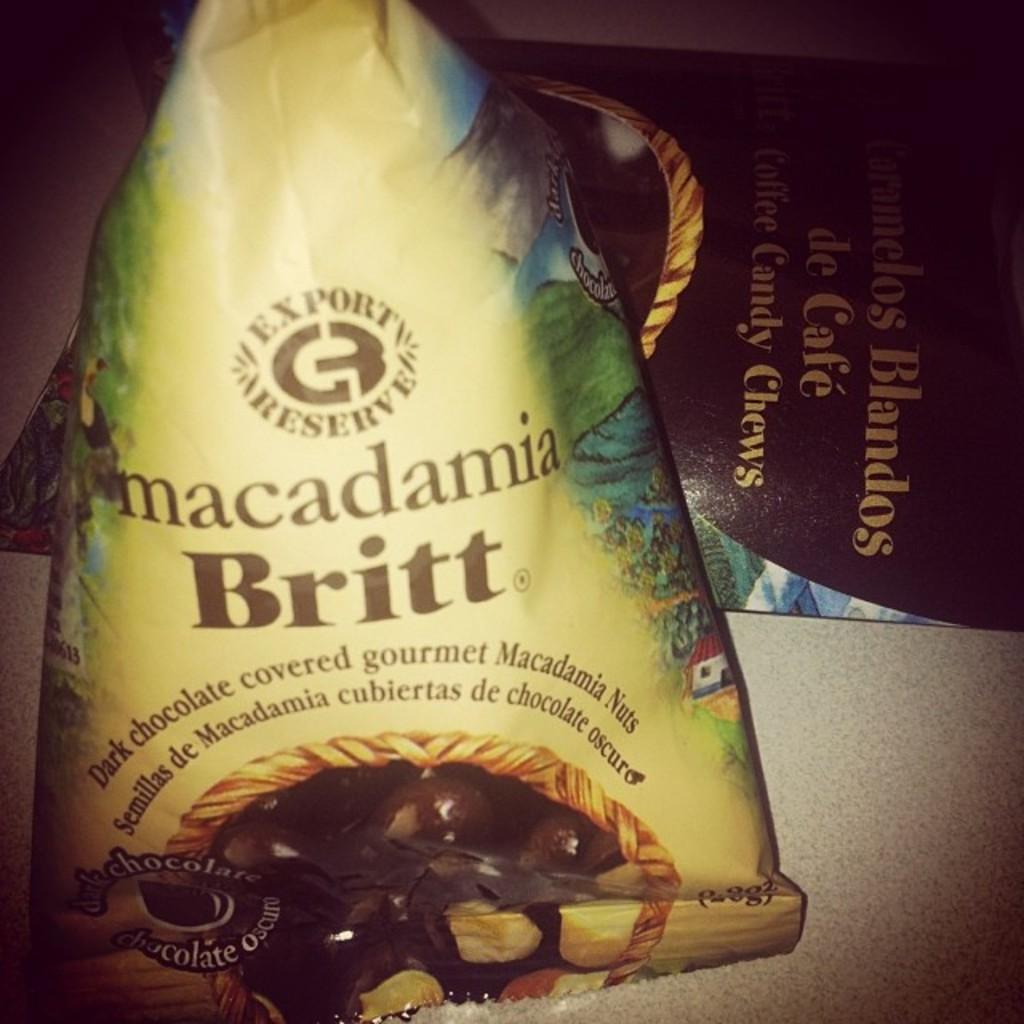What type of sweet tasting product covers the nuts?
Ensure brevity in your answer.  Dark chocolate. 